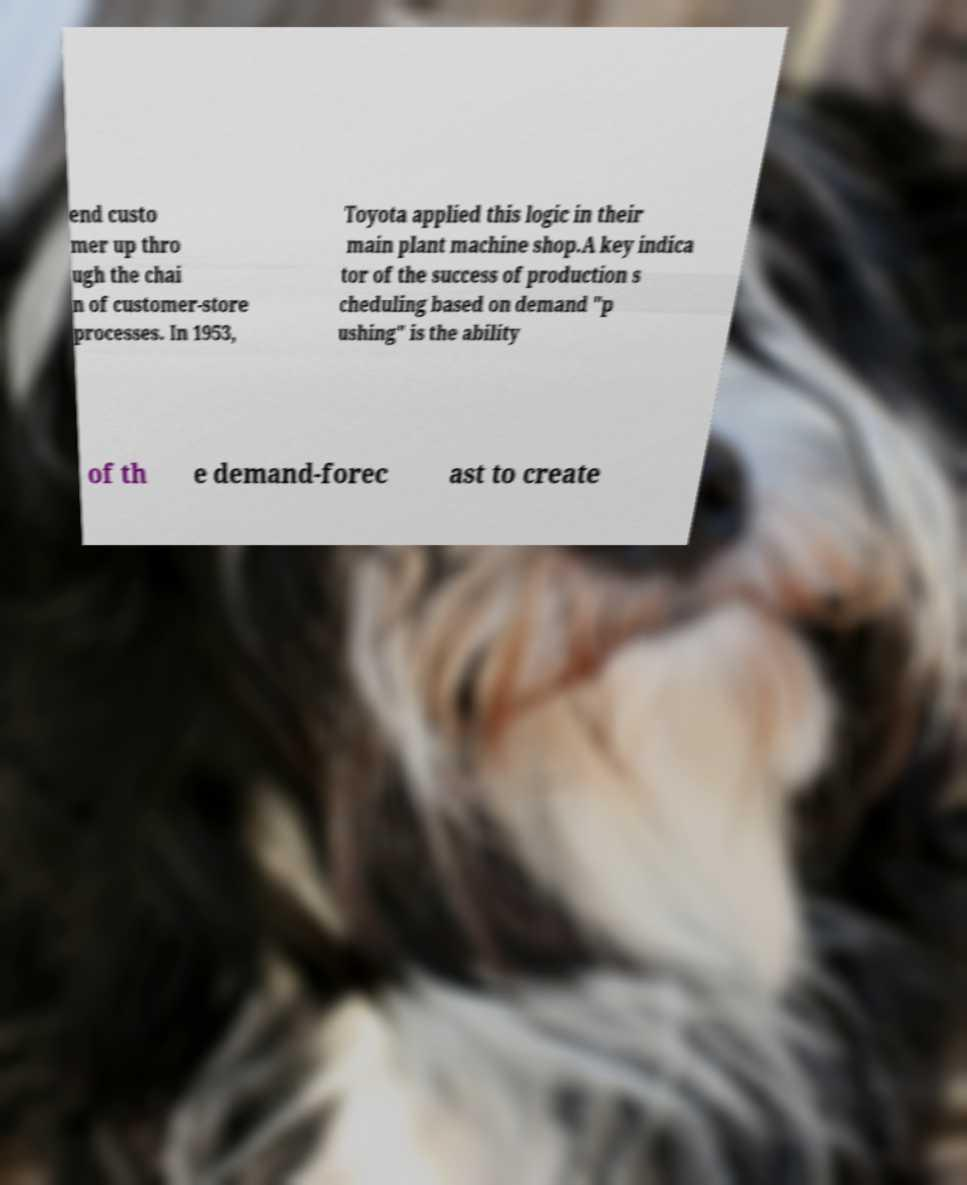What messages or text are displayed in this image? I need them in a readable, typed format. end custo mer up thro ugh the chai n of customer-store processes. In 1953, Toyota applied this logic in their main plant machine shop.A key indica tor of the success of production s cheduling based on demand "p ushing" is the ability of th e demand-forec ast to create 